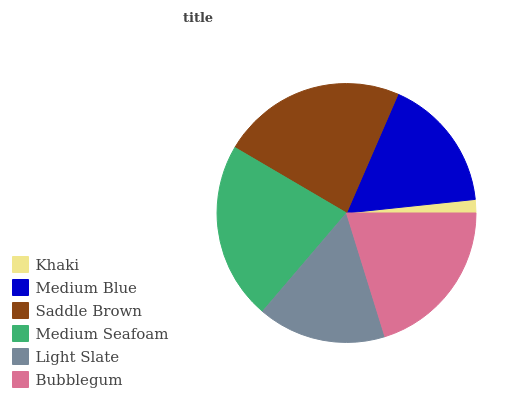Is Khaki the minimum?
Answer yes or no. Yes. Is Saddle Brown the maximum?
Answer yes or no. Yes. Is Medium Blue the minimum?
Answer yes or no. No. Is Medium Blue the maximum?
Answer yes or no. No. Is Medium Blue greater than Khaki?
Answer yes or no. Yes. Is Khaki less than Medium Blue?
Answer yes or no. Yes. Is Khaki greater than Medium Blue?
Answer yes or no. No. Is Medium Blue less than Khaki?
Answer yes or no. No. Is Bubblegum the high median?
Answer yes or no. Yes. Is Medium Blue the low median?
Answer yes or no. Yes. Is Medium Seafoam the high median?
Answer yes or no. No. Is Medium Seafoam the low median?
Answer yes or no. No. 